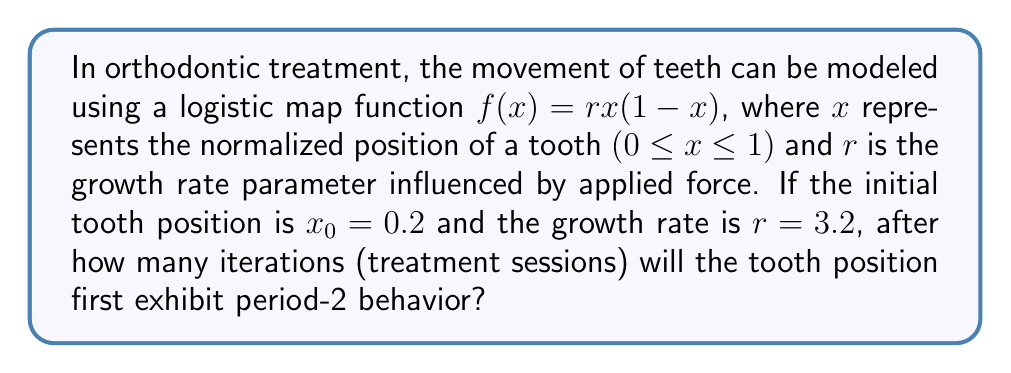Can you solve this math problem? To solve this problem, we need to apply bifurcation theory and iterate the logistic map function until we observe period-2 behavior. Let's follow these steps:

1) The logistic map function is given by $f(x) = rx(1-x)$ with $r = 3.2$ and $x_0 = 0.2$.

2) We need to iterate this function: $x_{n+1} = f(x_n) = 3.2x_n(1-x_n)$

3) Let's calculate the first few iterations:
   $x_1 = 3.2(0.2)(1-0.2) = 0.512$
   $x_2 = 3.2(0.512)(1-0.512) \approx 0.799795$
   $x_3 = 3.2(0.799795)(1-0.799795) \approx 0.513401$
   $x_4 = 3.2(0.513401)(1-0.513401) \approx 0.799069$
   $x_5 = 3.2(0.799069)(1-0.799069) \approx 0.513878$

4) We observe that after the 3rd iteration, the values start to alternate between two points (approximately 0.513 and 0.799). This indicates period-2 behavior.

5) To confirm, we can check if $f(f(x)) = x$ for these points:
   $f(f(0.513878)) \approx 0.513878$
   $f(f(0.799069)) \approx 0.799069$

6) Therefore, the tooth position first exhibits period-2 behavior after 3 iterations.
Answer: 3 iterations 